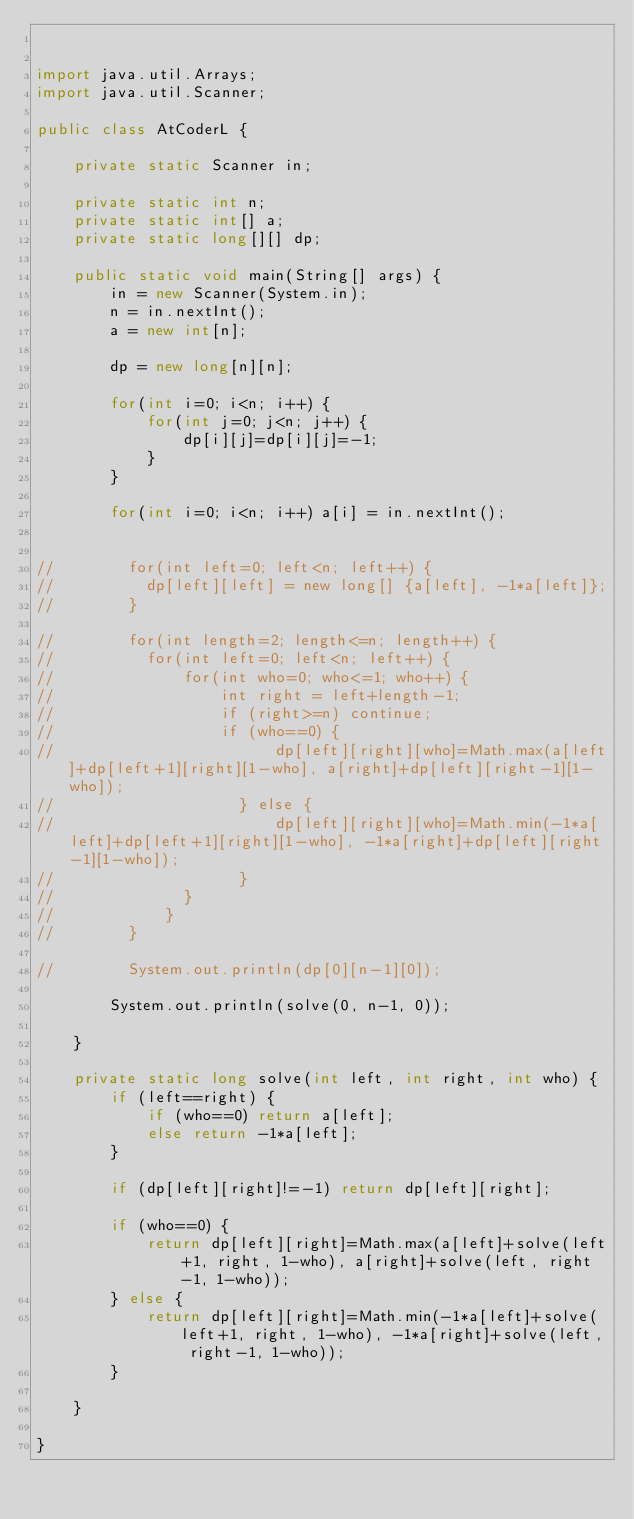<code> <loc_0><loc_0><loc_500><loc_500><_Java_>

import java.util.Arrays;
import java.util.Scanner;

public class AtCoderL {

	private static Scanner in;

    private static int n;
    private static int[] a;
    private static long[][] dp;

    public static void main(String[] args) {
        in = new Scanner(System.in);
        n = in.nextInt();
        a = new int[n];
        
        dp = new long[n][n];
        
        for(int i=0; i<n; i++) {
        	for(int j=0; j<n; j++) {
        		dp[i][j]=dp[i][j]=-1;
        	}
        }

        for(int i=0; i<n; i++) a[i] = in.nextInt();

        
//        for(int left=0; left<n; left++) {
//    		dp[left][left] = new long[] {a[left], -1*a[left]};
//        }
        
//        for(int length=2; length<=n; length++) {
//        	for(int left=0; left<n; left++) {
//            	for(int who=0; who<=1; who++) {
//                	int right = left+length-1;
//                	if (right>=n) continue;
//                	if (who==0) {
//                        dp[left][right][who]=Math.max(a[left]+dp[left+1][right][1-who], a[right]+dp[left][right-1][1-who]);
//                    } else {
//                        dp[left][right][who]=Math.min(-1*a[left]+dp[left+1][right][1-who], -1*a[right]+dp[left][right-1][1-who]);
//                    }
//            	}
//            }
//        }
        
//        System.out.println(dp[0][n-1][0]);
        
        System.out.println(solve(0, n-1, 0));

    }
    
    private static long solve(int left, int right, int who) {
        if (left==right) {
            if (who==0) return a[left];
            else return -1*a[left];
        } 
        
        if (dp[left][right]!=-1) return dp[left][right];

        if (who==0) {
            return dp[left][right]=Math.max(a[left]+solve(left+1, right, 1-who), a[right]+solve(left, right-1, 1-who));
        } else {
            return dp[left][right]=Math.min(-1*a[left]+solve(left+1, right, 1-who), -1*a[right]+solve(left, right-1, 1-who));
        }

    }

}
</code> 